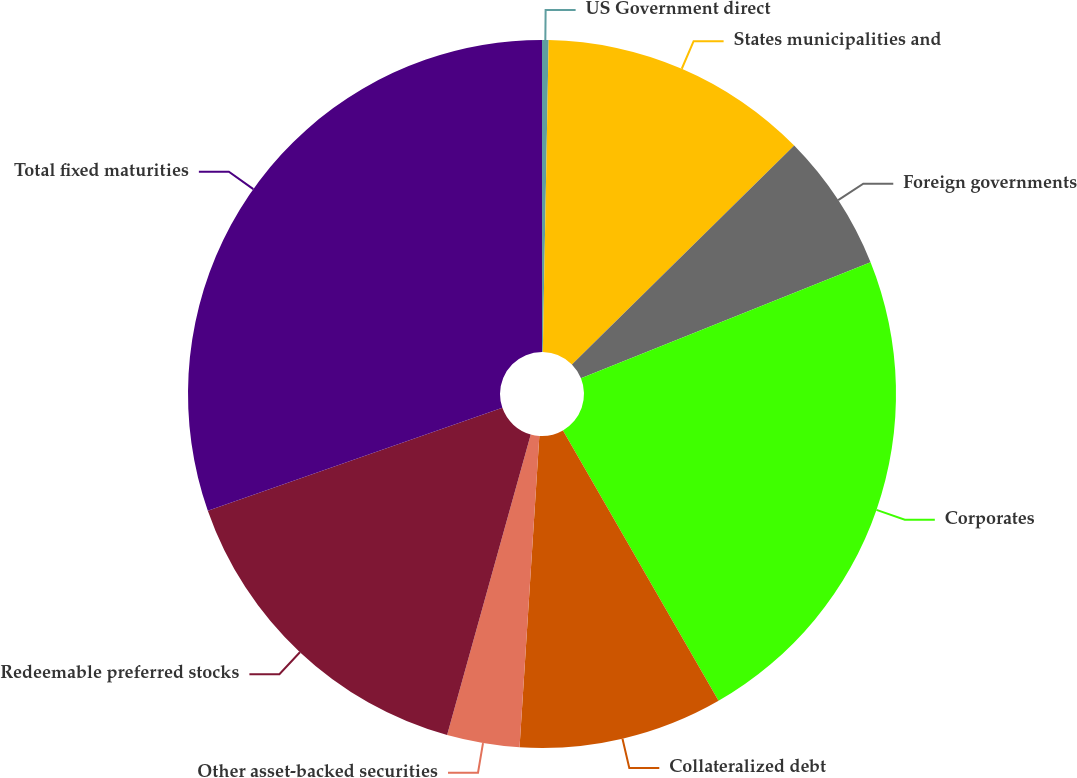Convert chart. <chart><loc_0><loc_0><loc_500><loc_500><pie_chart><fcel>US Government direct<fcel>States municipalities and<fcel>Foreign governments<fcel>Corporates<fcel>Collateralized debt<fcel>Other asset-backed securities<fcel>Redeemable preferred stocks<fcel>Total fixed maturities<nl><fcel>0.3%<fcel>12.32%<fcel>6.31%<fcel>22.76%<fcel>9.32%<fcel>3.31%<fcel>15.33%<fcel>30.35%<nl></chart> 